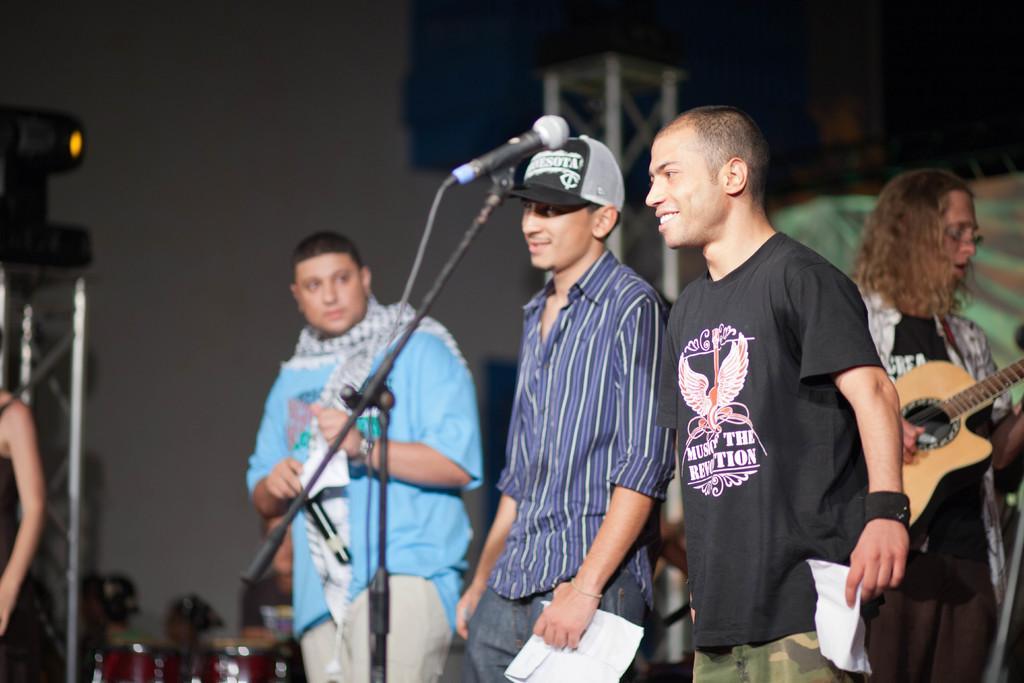Describe this image in one or two sentences. In this image there are five people standing. There is a mic and a stand. 